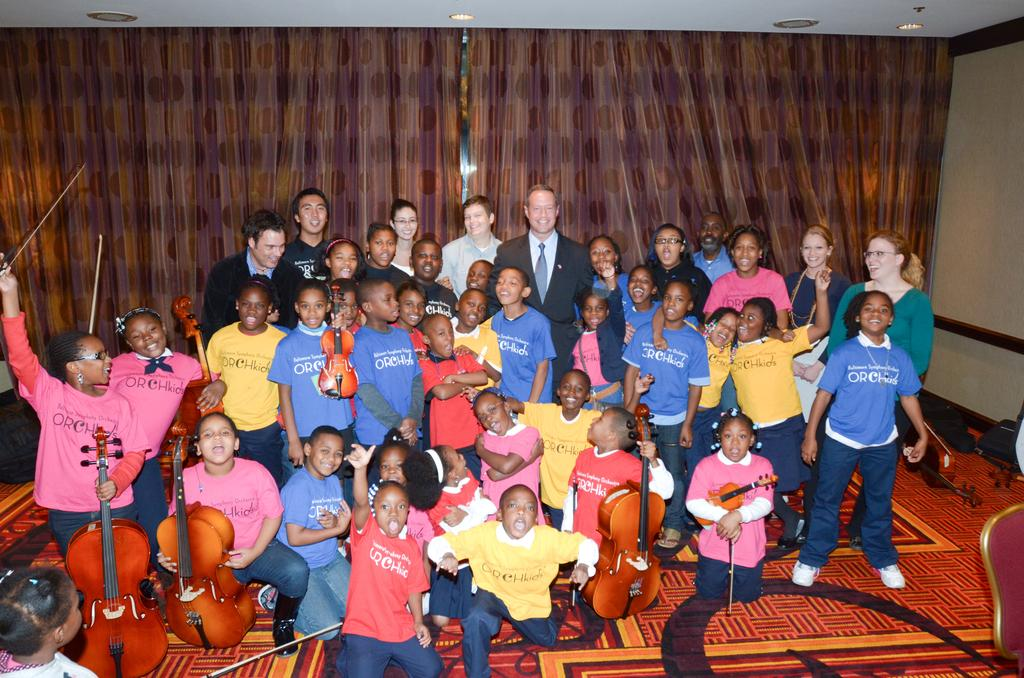What is the main subject of the image? The main subject of the image is a group of people. What are the people in the image doing? Some people are standing, while others are sitting, and they are holding musical instruments. What can be seen in the background of the image? There are two brown curtains in the background of the image. What type of religious ceremony is taking place in the image? There is no indication of a religious ceremony in the image; the people are holding musical instruments, which suggests they might be a musical group or performers. Can you see a railway track in the image? There is no railway track present in the image. 